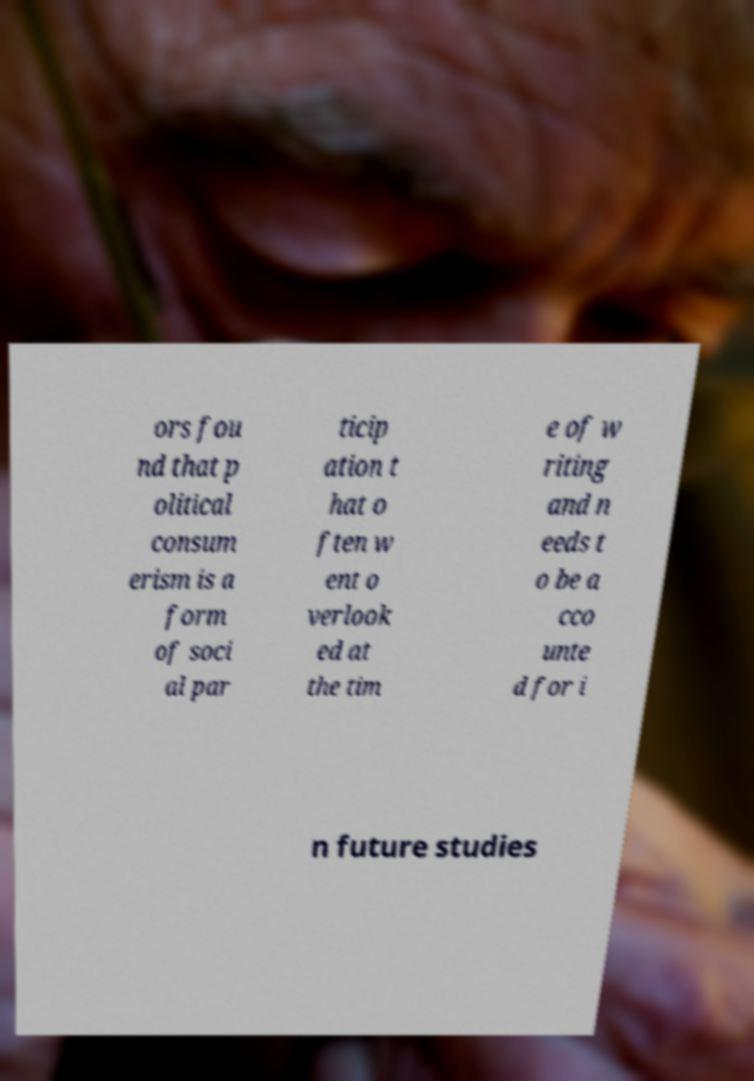What messages or text are displayed in this image? I need them in a readable, typed format. ors fou nd that p olitical consum erism is a form of soci al par ticip ation t hat o ften w ent o verlook ed at the tim e of w riting and n eeds t o be a cco unte d for i n future studies 